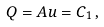<formula> <loc_0><loc_0><loc_500><loc_500>Q = A u = C _ { 1 } \, ,</formula> 